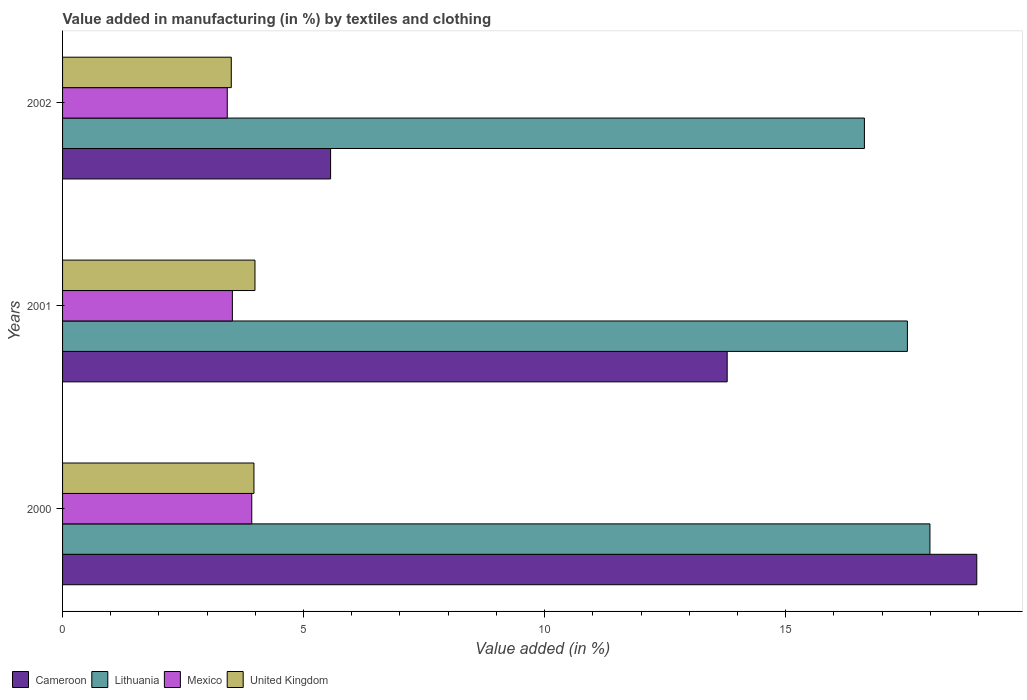How many different coloured bars are there?
Offer a very short reply. 4. How many groups of bars are there?
Your answer should be very brief. 3. Are the number of bars per tick equal to the number of legend labels?
Your answer should be very brief. Yes. Are the number of bars on each tick of the Y-axis equal?
Your answer should be compact. Yes. How many bars are there on the 1st tick from the top?
Your answer should be very brief. 4. How many bars are there on the 3rd tick from the bottom?
Your answer should be compact. 4. What is the label of the 3rd group of bars from the top?
Give a very brief answer. 2000. In how many cases, is the number of bars for a given year not equal to the number of legend labels?
Your answer should be compact. 0. What is the percentage of value added in manufacturing by textiles and clothing in Mexico in 2001?
Make the answer very short. 3.52. Across all years, what is the maximum percentage of value added in manufacturing by textiles and clothing in Cameroon?
Your answer should be compact. 18.97. Across all years, what is the minimum percentage of value added in manufacturing by textiles and clothing in Mexico?
Give a very brief answer. 3.42. What is the total percentage of value added in manufacturing by textiles and clothing in Mexico in the graph?
Offer a very short reply. 10.86. What is the difference between the percentage of value added in manufacturing by textiles and clothing in Cameroon in 2000 and that in 2001?
Ensure brevity in your answer.  5.18. What is the difference between the percentage of value added in manufacturing by textiles and clothing in United Kingdom in 2000 and the percentage of value added in manufacturing by textiles and clothing in Lithuania in 2001?
Give a very brief answer. -13.56. What is the average percentage of value added in manufacturing by textiles and clothing in Cameroon per year?
Your answer should be compact. 12.77. In the year 2001, what is the difference between the percentage of value added in manufacturing by textiles and clothing in Cameroon and percentage of value added in manufacturing by textiles and clothing in Lithuania?
Offer a very short reply. -3.74. What is the ratio of the percentage of value added in manufacturing by textiles and clothing in Lithuania in 2000 to that in 2001?
Ensure brevity in your answer.  1.03. Is the percentage of value added in manufacturing by textiles and clothing in Cameroon in 2000 less than that in 2002?
Offer a very short reply. No. What is the difference between the highest and the second highest percentage of value added in manufacturing by textiles and clothing in Mexico?
Keep it short and to the point. 0.4. What is the difference between the highest and the lowest percentage of value added in manufacturing by textiles and clothing in United Kingdom?
Make the answer very short. 0.49. In how many years, is the percentage of value added in manufacturing by textiles and clothing in Lithuania greater than the average percentage of value added in manufacturing by textiles and clothing in Lithuania taken over all years?
Ensure brevity in your answer.  2. Is it the case that in every year, the sum of the percentage of value added in manufacturing by textiles and clothing in Mexico and percentage of value added in manufacturing by textiles and clothing in United Kingdom is greater than the sum of percentage of value added in manufacturing by textiles and clothing in Cameroon and percentage of value added in manufacturing by textiles and clothing in Lithuania?
Ensure brevity in your answer.  No. What does the 3rd bar from the bottom in 2001 represents?
Your answer should be very brief. Mexico. What is the difference between two consecutive major ticks on the X-axis?
Provide a succinct answer. 5. Are the values on the major ticks of X-axis written in scientific E-notation?
Your response must be concise. No. Does the graph contain grids?
Your answer should be compact. No. Where does the legend appear in the graph?
Your response must be concise. Bottom left. What is the title of the graph?
Provide a short and direct response. Value added in manufacturing (in %) by textiles and clothing. What is the label or title of the X-axis?
Your answer should be very brief. Value added (in %). What is the Value added (in %) of Cameroon in 2000?
Your response must be concise. 18.97. What is the Value added (in %) in Lithuania in 2000?
Provide a short and direct response. 17.99. What is the Value added (in %) of Mexico in 2000?
Make the answer very short. 3.92. What is the Value added (in %) of United Kingdom in 2000?
Ensure brevity in your answer.  3.97. What is the Value added (in %) in Cameroon in 2001?
Offer a very short reply. 13.79. What is the Value added (in %) in Lithuania in 2001?
Make the answer very short. 17.53. What is the Value added (in %) in Mexico in 2001?
Give a very brief answer. 3.52. What is the Value added (in %) of United Kingdom in 2001?
Offer a very short reply. 3.99. What is the Value added (in %) in Cameroon in 2002?
Provide a succinct answer. 5.56. What is the Value added (in %) in Lithuania in 2002?
Offer a very short reply. 16.63. What is the Value added (in %) in Mexico in 2002?
Your response must be concise. 3.42. What is the Value added (in %) in United Kingdom in 2002?
Provide a short and direct response. 3.5. Across all years, what is the maximum Value added (in %) in Cameroon?
Provide a short and direct response. 18.97. Across all years, what is the maximum Value added (in %) of Lithuania?
Give a very brief answer. 17.99. Across all years, what is the maximum Value added (in %) in Mexico?
Ensure brevity in your answer.  3.92. Across all years, what is the maximum Value added (in %) of United Kingdom?
Provide a succinct answer. 3.99. Across all years, what is the minimum Value added (in %) of Cameroon?
Provide a succinct answer. 5.56. Across all years, what is the minimum Value added (in %) of Lithuania?
Your response must be concise. 16.63. Across all years, what is the minimum Value added (in %) in Mexico?
Provide a short and direct response. 3.42. Across all years, what is the minimum Value added (in %) in United Kingdom?
Ensure brevity in your answer.  3.5. What is the total Value added (in %) in Cameroon in the graph?
Provide a succinct answer. 38.31. What is the total Value added (in %) of Lithuania in the graph?
Provide a short and direct response. 52.15. What is the total Value added (in %) of Mexico in the graph?
Keep it short and to the point. 10.86. What is the total Value added (in %) of United Kingdom in the graph?
Provide a short and direct response. 11.46. What is the difference between the Value added (in %) in Cameroon in 2000 and that in 2001?
Offer a terse response. 5.18. What is the difference between the Value added (in %) in Lithuania in 2000 and that in 2001?
Make the answer very short. 0.47. What is the difference between the Value added (in %) of Mexico in 2000 and that in 2001?
Your answer should be very brief. 0.4. What is the difference between the Value added (in %) in United Kingdom in 2000 and that in 2001?
Keep it short and to the point. -0.02. What is the difference between the Value added (in %) of Cameroon in 2000 and that in 2002?
Your answer should be compact. 13.41. What is the difference between the Value added (in %) of Lithuania in 2000 and that in 2002?
Give a very brief answer. 1.36. What is the difference between the Value added (in %) in Mexico in 2000 and that in 2002?
Give a very brief answer. 0.51. What is the difference between the Value added (in %) in United Kingdom in 2000 and that in 2002?
Provide a succinct answer. 0.47. What is the difference between the Value added (in %) in Cameroon in 2001 and that in 2002?
Make the answer very short. 8.23. What is the difference between the Value added (in %) of Lithuania in 2001 and that in 2002?
Give a very brief answer. 0.89. What is the difference between the Value added (in %) of Mexico in 2001 and that in 2002?
Your response must be concise. 0.11. What is the difference between the Value added (in %) in United Kingdom in 2001 and that in 2002?
Ensure brevity in your answer.  0.49. What is the difference between the Value added (in %) of Cameroon in 2000 and the Value added (in %) of Lithuania in 2001?
Your answer should be very brief. 1.44. What is the difference between the Value added (in %) in Cameroon in 2000 and the Value added (in %) in Mexico in 2001?
Make the answer very short. 15.44. What is the difference between the Value added (in %) in Cameroon in 2000 and the Value added (in %) in United Kingdom in 2001?
Offer a terse response. 14.97. What is the difference between the Value added (in %) in Lithuania in 2000 and the Value added (in %) in Mexico in 2001?
Offer a terse response. 14.47. What is the difference between the Value added (in %) in Lithuania in 2000 and the Value added (in %) in United Kingdom in 2001?
Keep it short and to the point. 14. What is the difference between the Value added (in %) of Mexico in 2000 and the Value added (in %) of United Kingdom in 2001?
Make the answer very short. -0.07. What is the difference between the Value added (in %) in Cameroon in 2000 and the Value added (in %) in Lithuania in 2002?
Provide a succinct answer. 2.33. What is the difference between the Value added (in %) in Cameroon in 2000 and the Value added (in %) in Mexico in 2002?
Your answer should be very brief. 15.55. What is the difference between the Value added (in %) of Cameroon in 2000 and the Value added (in %) of United Kingdom in 2002?
Your answer should be very brief. 15.47. What is the difference between the Value added (in %) of Lithuania in 2000 and the Value added (in %) of Mexico in 2002?
Ensure brevity in your answer.  14.58. What is the difference between the Value added (in %) of Lithuania in 2000 and the Value added (in %) of United Kingdom in 2002?
Your response must be concise. 14.49. What is the difference between the Value added (in %) in Mexico in 2000 and the Value added (in %) in United Kingdom in 2002?
Ensure brevity in your answer.  0.42. What is the difference between the Value added (in %) of Cameroon in 2001 and the Value added (in %) of Lithuania in 2002?
Your answer should be compact. -2.85. What is the difference between the Value added (in %) in Cameroon in 2001 and the Value added (in %) in Mexico in 2002?
Provide a short and direct response. 10.37. What is the difference between the Value added (in %) in Cameroon in 2001 and the Value added (in %) in United Kingdom in 2002?
Your answer should be compact. 10.29. What is the difference between the Value added (in %) of Lithuania in 2001 and the Value added (in %) of Mexico in 2002?
Offer a terse response. 14.11. What is the difference between the Value added (in %) of Lithuania in 2001 and the Value added (in %) of United Kingdom in 2002?
Provide a short and direct response. 14.03. What is the difference between the Value added (in %) of Mexico in 2001 and the Value added (in %) of United Kingdom in 2002?
Provide a succinct answer. 0.02. What is the average Value added (in %) of Cameroon per year?
Make the answer very short. 12.77. What is the average Value added (in %) in Lithuania per year?
Give a very brief answer. 17.38. What is the average Value added (in %) in Mexico per year?
Your answer should be compact. 3.62. What is the average Value added (in %) in United Kingdom per year?
Provide a succinct answer. 3.82. In the year 2000, what is the difference between the Value added (in %) of Cameroon and Value added (in %) of Lithuania?
Give a very brief answer. 0.97. In the year 2000, what is the difference between the Value added (in %) of Cameroon and Value added (in %) of Mexico?
Ensure brevity in your answer.  15.04. In the year 2000, what is the difference between the Value added (in %) of Cameroon and Value added (in %) of United Kingdom?
Offer a very short reply. 15. In the year 2000, what is the difference between the Value added (in %) of Lithuania and Value added (in %) of Mexico?
Offer a very short reply. 14.07. In the year 2000, what is the difference between the Value added (in %) of Lithuania and Value added (in %) of United Kingdom?
Offer a terse response. 14.02. In the year 2000, what is the difference between the Value added (in %) in Mexico and Value added (in %) in United Kingdom?
Give a very brief answer. -0.05. In the year 2001, what is the difference between the Value added (in %) of Cameroon and Value added (in %) of Lithuania?
Your answer should be compact. -3.74. In the year 2001, what is the difference between the Value added (in %) in Cameroon and Value added (in %) in Mexico?
Ensure brevity in your answer.  10.26. In the year 2001, what is the difference between the Value added (in %) in Cameroon and Value added (in %) in United Kingdom?
Your response must be concise. 9.8. In the year 2001, what is the difference between the Value added (in %) of Lithuania and Value added (in %) of Mexico?
Provide a succinct answer. 14. In the year 2001, what is the difference between the Value added (in %) in Lithuania and Value added (in %) in United Kingdom?
Ensure brevity in your answer.  13.54. In the year 2001, what is the difference between the Value added (in %) of Mexico and Value added (in %) of United Kingdom?
Offer a terse response. -0.47. In the year 2002, what is the difference between the Value added (in %) in Cameroon and Value added (in %) in Lithuania?
Provide a succinct answer. -11.07. In the year 2002, what is the difference between the Value added (in %) in Cameroon and Value added (in %) in Mexico?
Your answer should be compact. 2.14. In the year 2002, what is the difference between the Value added (in %) in Cameroon and Value added (in %) in United Kingdom?
Your answer should be compact. 2.06. In the year 2002, what is the difference between the Value added (in %) in Lithuania and Value added (in %) in Mexico?
Offer a terse response. 13.22. In the year 2002, what is the difference between the Value added (in %) in Lithuania and Value added (in %) in United Kingdom?
Your answer should be very brief. 13.13. In the year 2002, what is the difference between the Value added (in %) of Mexico and Value added (in %) of United Kingdom?
Your answer should be compact. -0.08. What is the ratio of the Value added (in %) of Cameroon in 2000 to that in 2001?
Give a very brief answer. 1.38. What is the ratio of the Value added (in %) of Lithuania in 2000 to that in 2001?
Make the answer very short. 1.03. What is the ratio of the Value added (in %) of Mexico in 2000 to that in 2001?
Offer a very short reply. 1.11. What is the ratio of the Value added (in %) of Cameroon in 2000 to that in 2002?
Provide a short and direct response. 3.41. What is the ratio of the Value added (in %) in Lithuania in 2000 to that in 2002?
Provide a succinct answer. 1.08. What is the ratio of the Value added (in %) in Mexico in 2000 to that in 2002?
Offer a very short reply. 1.15. What is the ratio of the Value added (in %) in United Kingdom in 2000 to that in 2002?
Give a very brief answer. 1.13. What is the ratio of the Value added (in %) in Cameroon in 2001 to that in 2002?
Give a very brief answer. 2.48. What is the ratio of the Value added (in %) in Lithuania in 2001 to that in 2002?
Ensure brevity in your answer.  1.05. What is the ratio of the Value added (in %) in Mexico in 2001 to that in 2002?
Provide a succinct answer. 1.03. What is the ratio of the Value added (in %) in United Kingdom in 2001 to that in 2002?
Provide a succinct answer. 1.14. What is the difference between the highest and the second highest Value added (in %) of Cameroon?
Provide a short and direct response. 5.18. What is the difference between the highest and the second highest Value added (in %) of Lithuania?
Make the answer very short. 0.47. What is the difference between the highest and the second highest Value added (in %) in Mexico?
Your answer should be compact. 0.4. What is the difference between the highest and the second highest Value added (in %) in United Kingdom?
Provide a short and direct response. 0.02. What is the difference between the highest and the lowest Value added (in %) in Cameroon?
Keep it short and to the point. 13.41. What is the difference between the highest and the lowest Value added (in %) in Lithuania?
Offer a very short reply. 1.36. What is the difference between the highest and the lowest Value added (in %) in Mexico?
Give a very brief answer. 0.51. What is the difference between the highest and the lowest Value added (in %) of United Kingdom?
Keep it short and to the point. 0.49. 